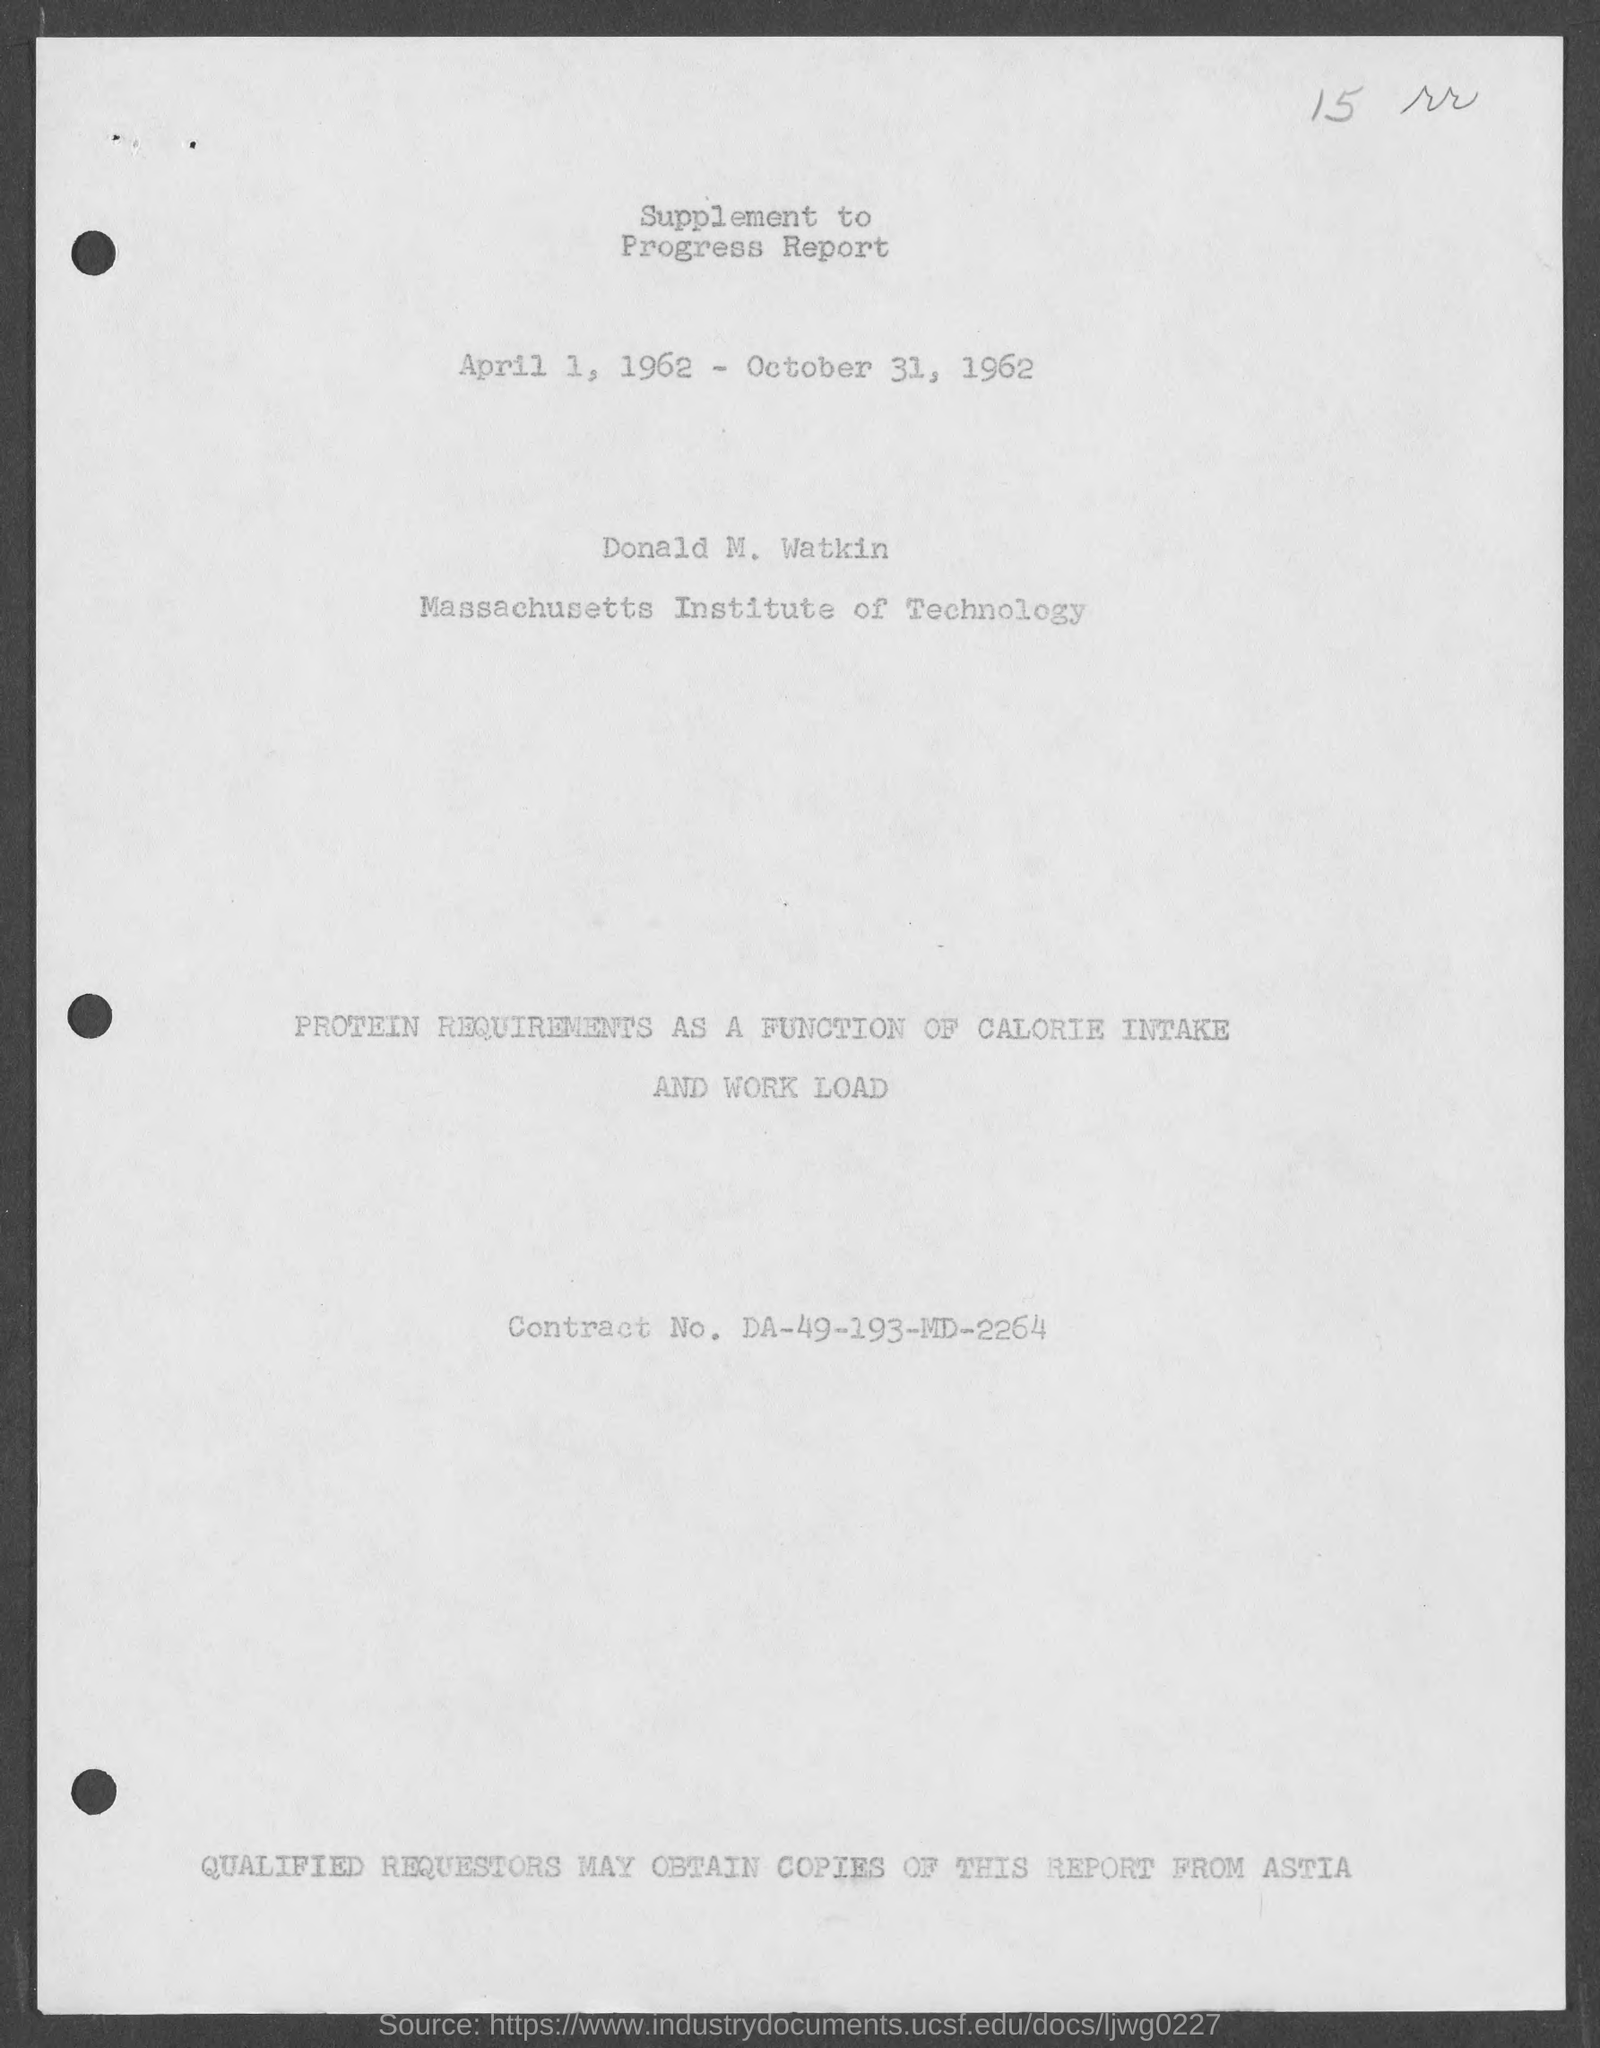Give some essential details in this illustration. The Contract No. given in the document is DA-49-193-MD-2264. The date mentioned in this document is April 1, 1962, and it ends on October 31, 1962. 